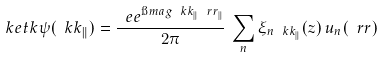Convert formula to latex. <formula><loc_0><loc_0><loc_500><loc_500>\ k e t k { \psi ( \ k k _ { \| } ) } = \frac { \ e e ^ { \i m a g \ k k _ { \| } \ r r _ { \| } } } { 2 \pi } \, \sum _ { n } \xi _ { n \ k k _ { \| } } ( z ) \, u _ { n } ( \ r r )</formula> 